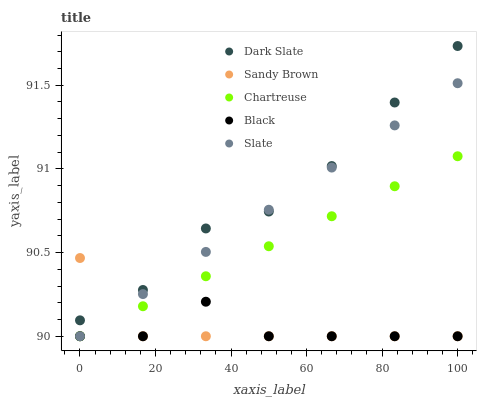Does Black have the minimum area under the curve?
Answer yes or no. Yes. Does Dark Slate have the maximum area under the curve?
Answer yes or no. Yes. Does Chartreuse have the minimum area under the curve?
Answer yes or no. No. Does Chartreuse have the maximum area under the curve?
Answer yes or no. No. Is Slate the smoothest?
Answer yes or no. Yes. Is Black the roughest?
Answer yes or no. Yes. Is Chartreuse the smoothest?
Answer yes or no. No. Is Chartreuse the roughest?
Answer yes or no. No. Does Chartreuse have the lowest value?
Answer yes or no. Yes. Does Dark Slate have the highest value?
Answer yes or no. Yes. Does Chartreuse have the highest value?
Answer yes or no. No. Is Black less than Dark Slate?
Answer yes or no. Yes. Is Dark Slate greater than Chartreuse?
Answer yes or no. Yes. Does Black intersect Sandy Brown?
Answer yes or no. Yes. Is Black less than Sandy Brown?
Answer yes or no. No. Is Black greater than Sandy Brown?
Answer yes or no. No. Does Black intersect Dark Slate?
Answer yes or no. No. 